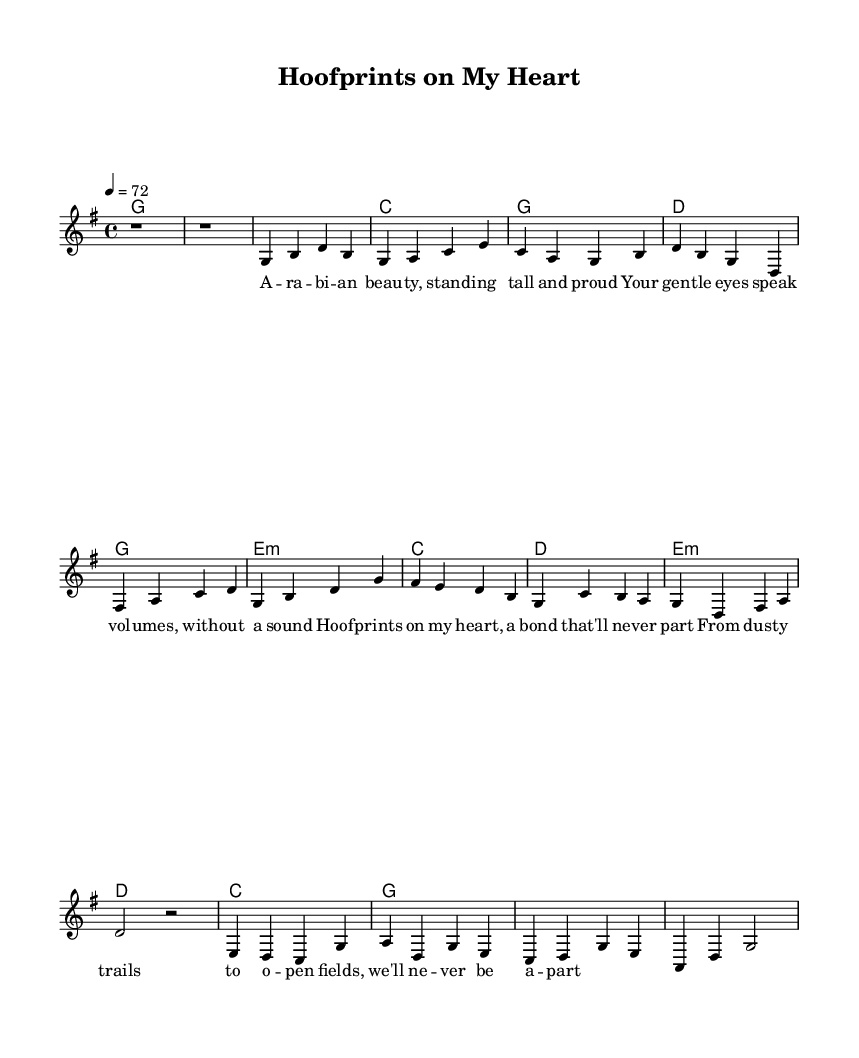What is the key signature of this music? The key signature indicated at the beginning of the piece shows one sharp, which is found in the G major scale. Therefore, the key signature is G major.
Answer: G major What is the time signature of this music? The time signature is listed as a fraction at the beginning of the piece, which reads 4 over 4. This indicates that there are four beats in each measure, and the quarter note gets one beat.
Answer: 4/4 What is the tempo marking for this piece? The tempo is indicated by a number at the beginning of the score, specifically written as 4 equals 72. This represents the beats per minute, indicating the speed of the music.
Answer: 72 What are the first two words of the lyrics? The lyrics are introduced with the lyric mode, starting with the first line from verse one. The first two words are derived from the text: "A" and "ra-bi-an".
Answer: A ra-bi-an How many measures are in the chorus? To determine the number of measures in the chorus, we can look at the notation shown in the music. The chorus section includes four measures indicated by the music notation presented directly after each verse section.
Answer: 4 Which chord is played during the bridge? The chord progression during the bridge is listed in the harmonies section. The first chord shown in the bridge is an E minor chord, as indicated by the chord symbols.
Answer: E minor 